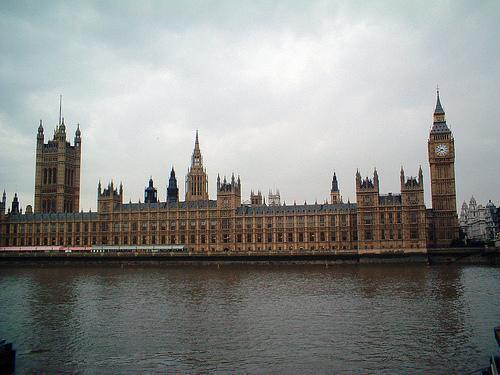How many clocks?
Give a very brief answer. 1. 